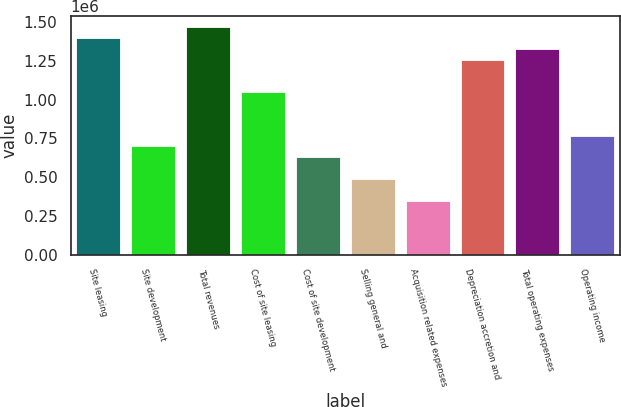Convert chart. <chart><loc_0><loc_0><loc_500><loc_500><bar_chart><fcel>Site leasing<fcel>Site development<fcel>Total revenues<fcel>Cost of site leasing<fcel>Cost of site development<fcel>Selling general and<fcel>Acquisition related expenses<fcel>Depreciation accretion and<fcel>Total operating expenses<fcel>Operating income<nl><fcel>1.39634e+06<fcel>698170<fcel>1.46616e+06<fcel>1.04725e+06<fcel>628353<fcel>488719<fcel>349086<fcel>1.25671e+06<fcel>1.32652e+06<fcel>767987<nl></chart> 